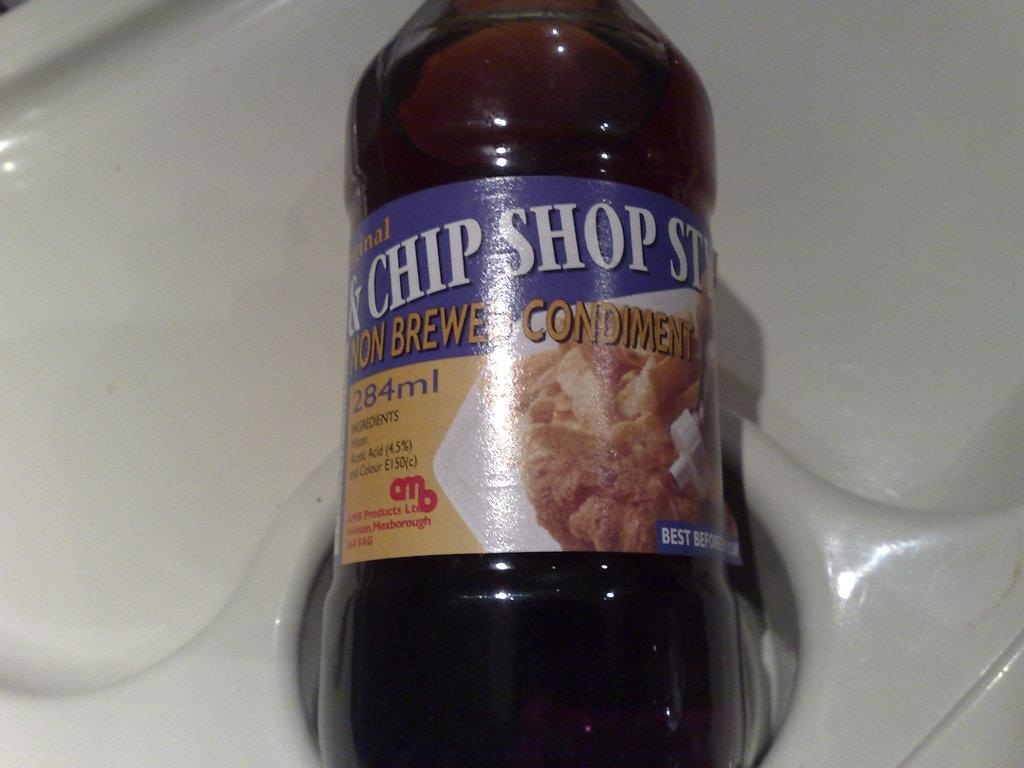<image>
Give a short and clear explanation of the subsequent image. A condiment bottle that says Chip Shop on it 